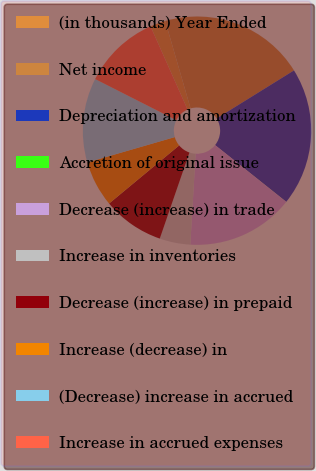<chart> <loc_0><loc_0><loc_500><loc_500><pie_chart><fcel>(in thousands) Year Ended<fcel>Net income<fcel>Depreciation and amortization<fcel>Accretion of original issue<fcel>Decrease (increase) in trade<fcel>Increase in inventories<fcel>Decrease (increase) in prepaid<fcel>Increase (decrease) in<fcel>(Decrease) increase in accrued<fcel>Increase in accrued expenses<nl><fcel>2.18%<fcel>20.64%<fcel>19.56%<fcel>0.01%<fcel>15.21%<fcel>4.35%<fcel>8.7%<fcel>6.53%<fcel>11.95%<fcel>10.87%<nl></chart> 